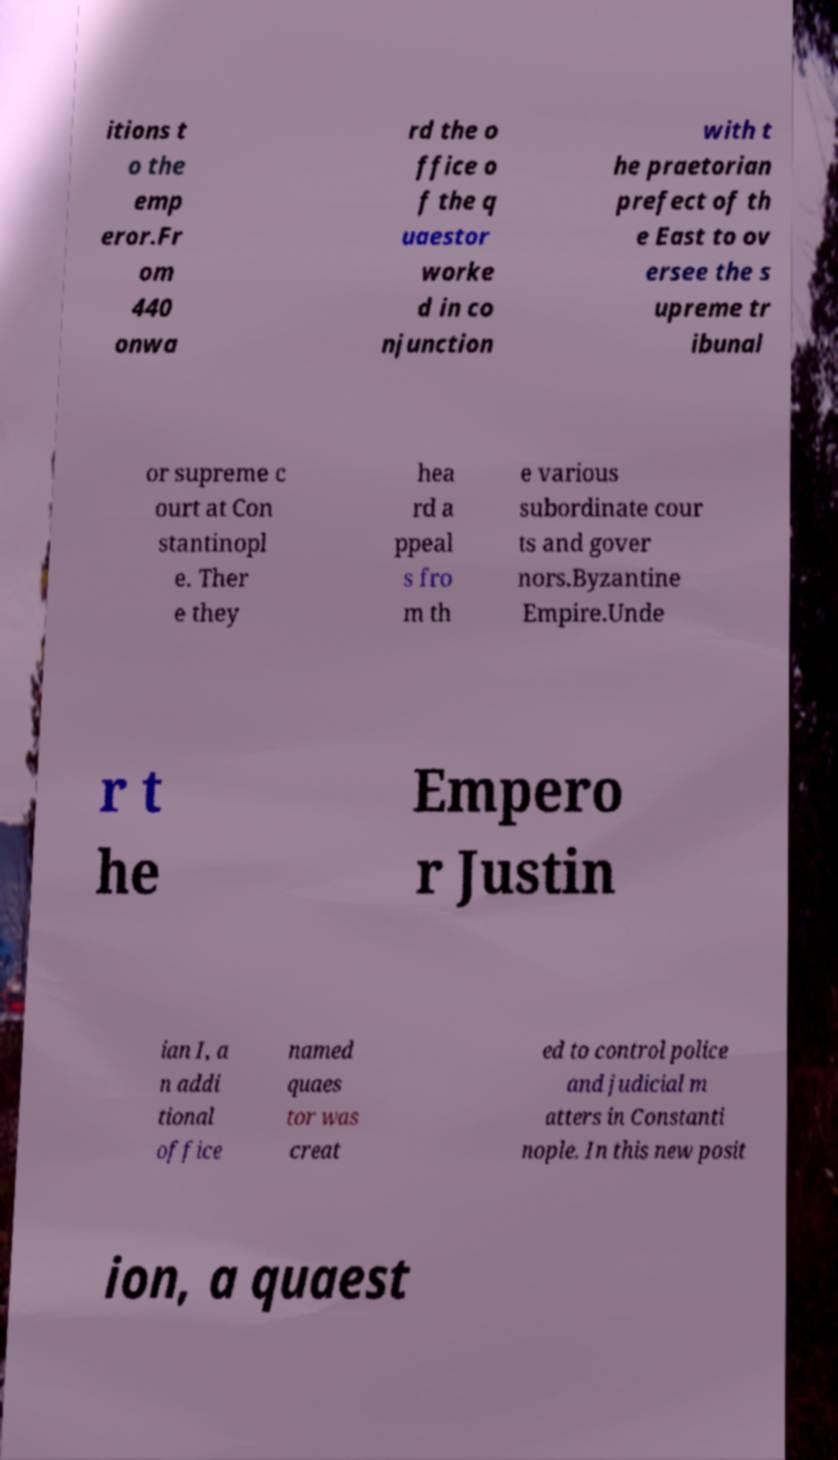Could you assist in decoding the text presented in this image and type it out clearly? itions t o the emp eror.Fr om 440 onwa rd the o ffice o f the q uaestor worke d in co njunction with t he praetorian prefect of th e East to ov ersee the s upreme tr ibunal or supreme c ourt at Con stantinopl e. Ther e they hea rd a ppeal s fro m th e various subordinate cour ts and gover nors.Byzantine Empire.Unde r t he Empero r Justin ian I, a n addi tional office named quaes tor was creat ed to control police and judicial m atters in Constanti nople. In this new posit ion, a quaest 